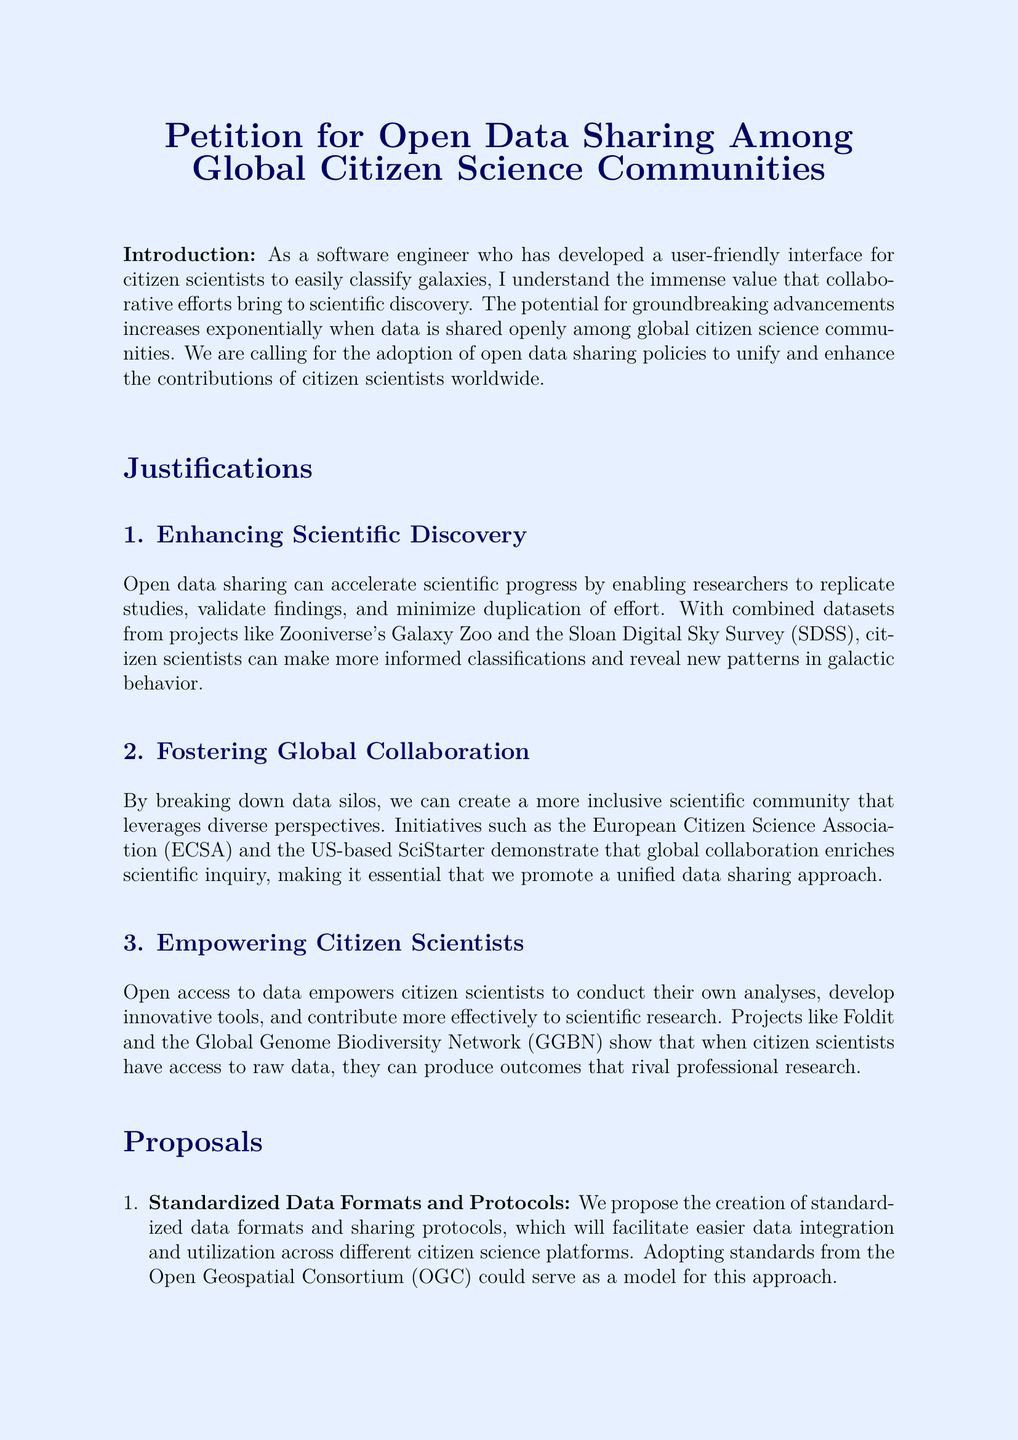What is the main call to action of the petition? The main call to action encourages commitments to open data sharing practices among policymakers, research institutions, and citizen science organizations.
Answer: Open data sharing practices Who supported this petition? The petition has supporters comprising leading scientists, respected research institutions, and enthusiastic citizen scientists across the globe.
Answer: Leading scientists, respected research institutions, and enthusiastic citizen scientists What organization is suggested for curating a centralized data repository? The document suggests the International Council for Science as the organization for curating a centralized data repository for citizen science data.
Answer: International Council for Science What is one of the justifications for open data sharing mentioned in the document? The document mentions enhancing scientific discovery as a justification for open data sharing.
Answer: Enhancing scientific discovery How many proposals are listed in the petition? There are three proposals outlined in the petition regarding open data sharing.
Answer: Three proposals Who is mentioned as an example signatory and associated with NASA? Dr. Jane Smith is mentioned as an example signatory associated with NASA.
Answer: Dr. Jane Smith What does the document propose regarding data formats and protocols? The document proposes the creation of standardized data formats and sharing protocols.
Answer: Standardized data formats and sharing protocols What ethical aspect is mentioned in the proposals? The proposals mention developing a robust legal and ethical framework for data sharing.
Answer: Legal and ethical framework 